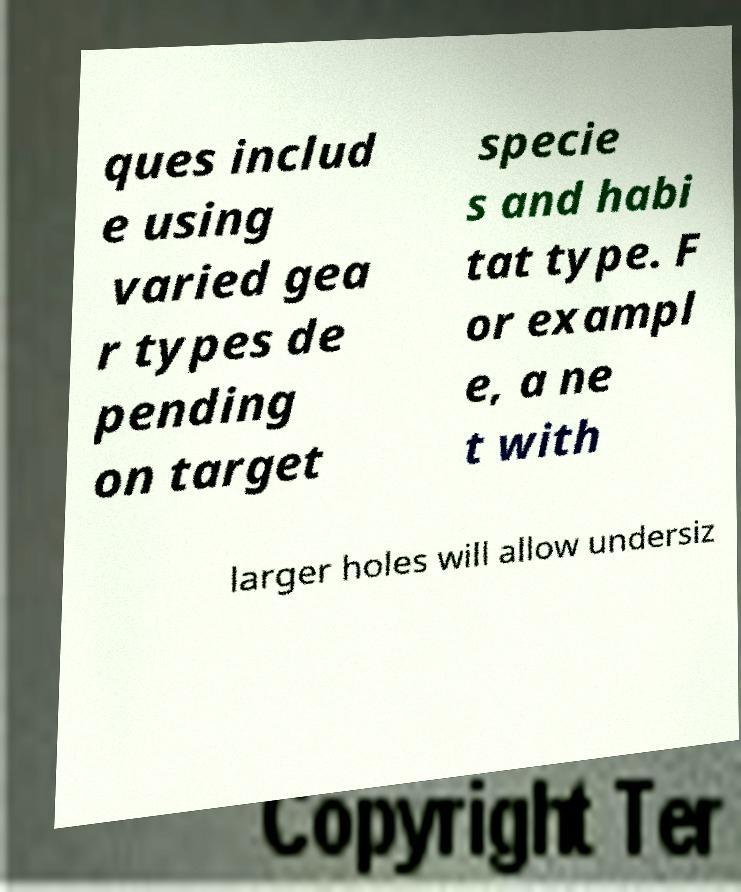Can you read and provide the text displayed in the image?This photo seems to have some interesting text. Can you extract and type it out for me? ques includ e using varied gea r types de pending on target specie s and habi tat type. F or exampl e, a ne t with larger holes will allow undersiz 